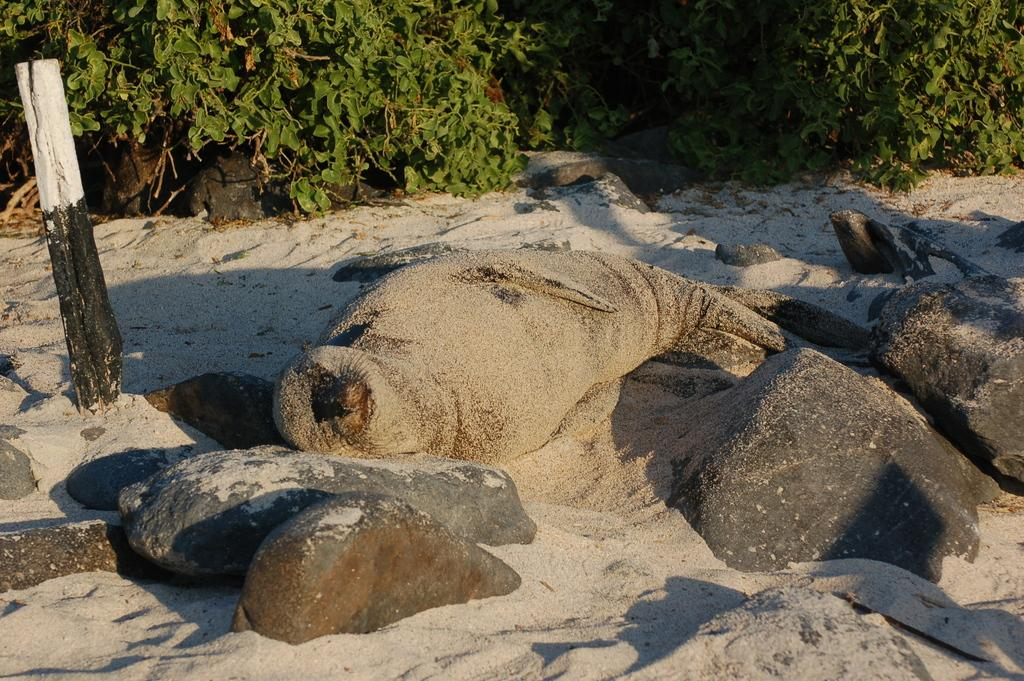What animal can be seen on the sand in the image? There is a seal on the sand in the image. What object is present in the image besides the seal? There is a pole in the image. What type of natural features can be seen in the image? There are rocks in the image. What can be seen in the background of the image? There are plants in the background of the image. What type of bone can be seen in the image? There is no bone present in the image. Can you describe the haircut of the seal in the image? Seals do not have hair, so there is no haircut to describe in the image. 